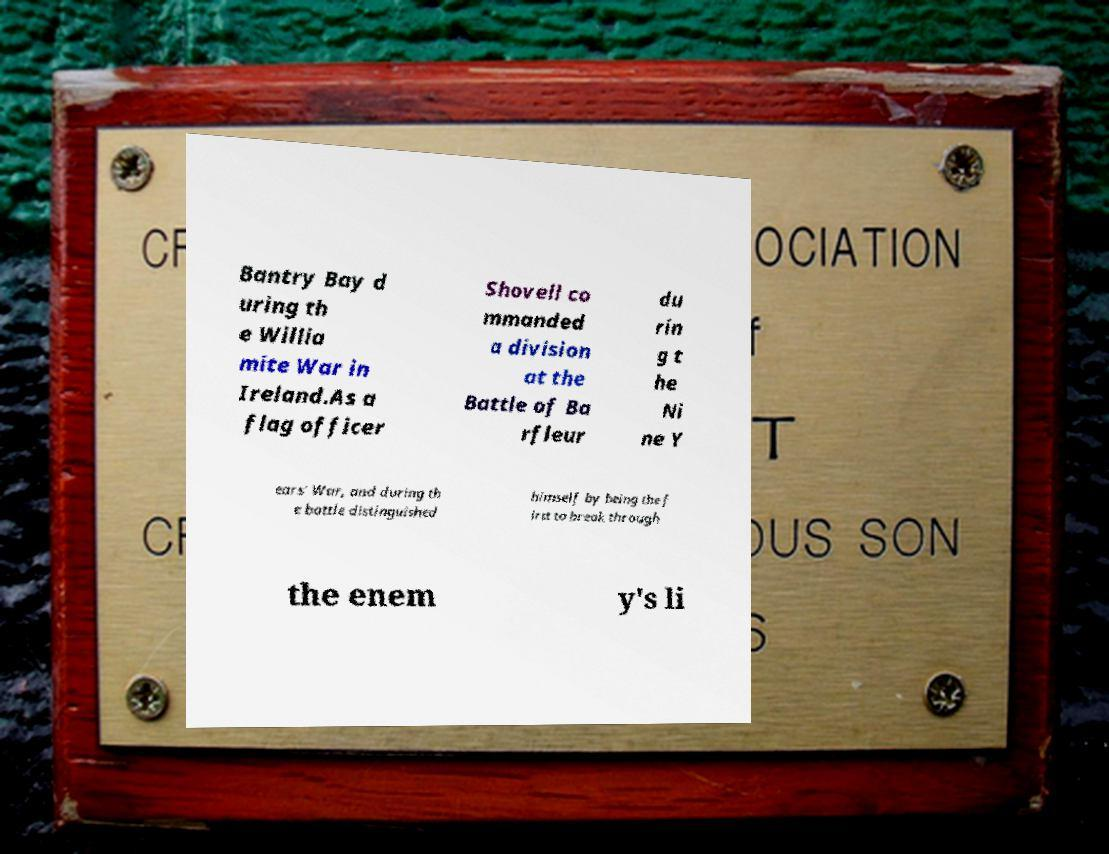What messages or text are displayed in this image? I need them in a readable, typed format. Bantry Bay d uring th e Willia mite War in Ireland.As a flag officer Shovell co mmanded a division at the Battle of Ba rfleur du rin g t he Ni ne Y ears' War, and during th e battle distinguished himself by being the f irst to break through the enem y's li 